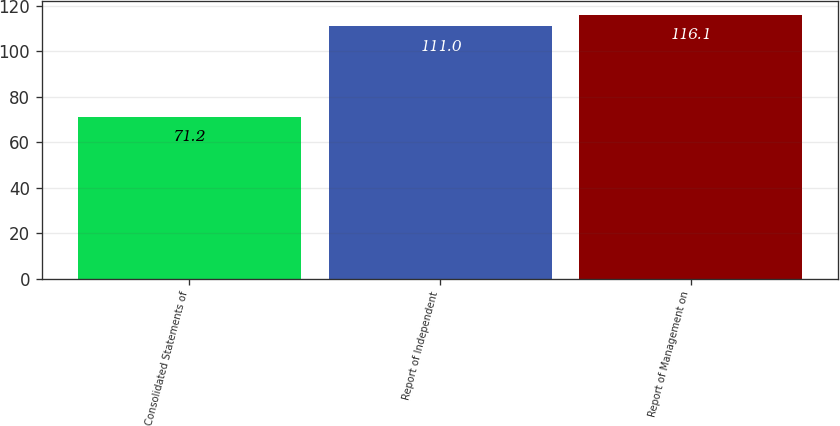<chart> <loc_0><loc_0><loc_500><loc_500><bar_chart><fcel>Consolidated Statements of<fcel>Report of Independent<fcel>Report of Management on<nl><fcel>71.2<fcel>111<fcel>116.1<nl></chart> 